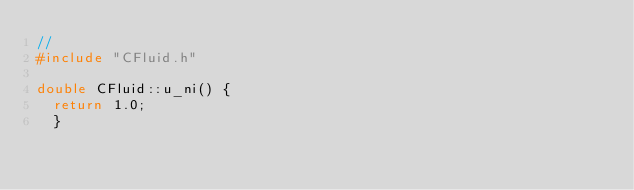Convert code to text. <code><loc_0><loc_0><loc_500><loc_500><_C++_>//
#include "CFluid.h"

double CFluid::u_ni() {
  return 1.0;
  }</code> 